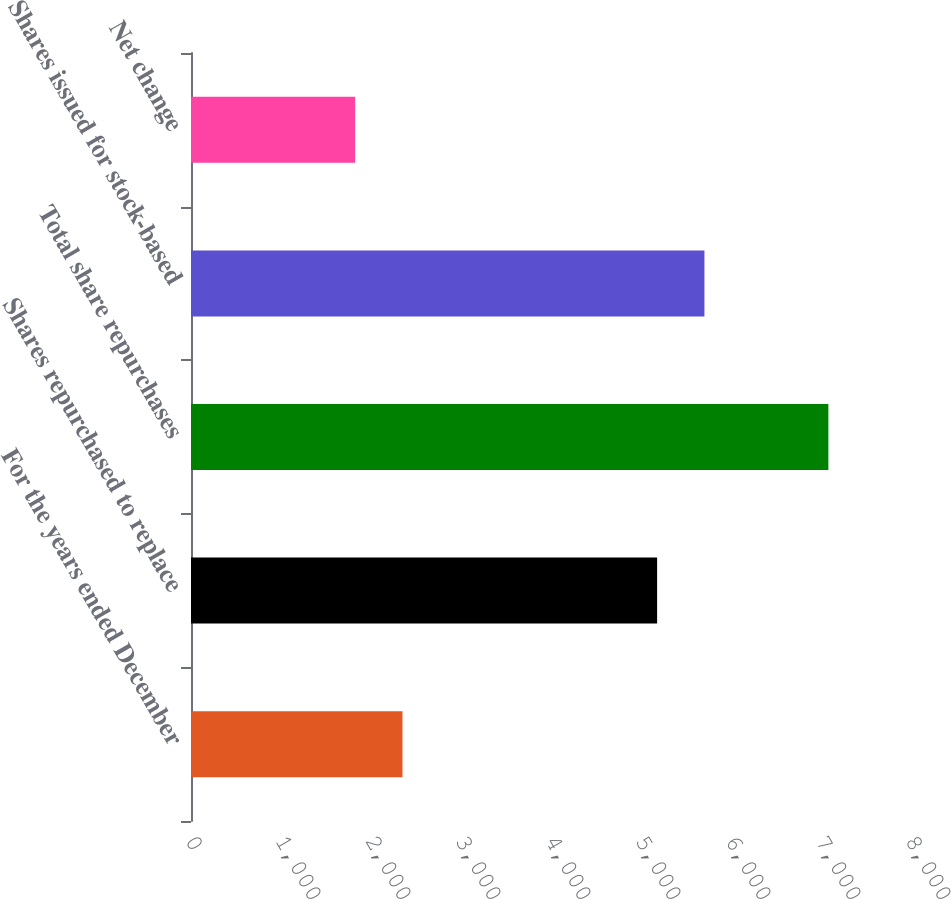Convert chart to OTSL. <chart><loc_0><loc_0><loc_500><loc_500><bar_chart><fcel>For the years ended December<fcel>Shares repurchased to replace<fcel>Total share repurchases<fcel>Shares issued for stock-based<fcel>Net change<nl><fcel>2349.8<fcel>5179<fcel>7082<fcel>5704.8<fcel>1824<nl></chart> 